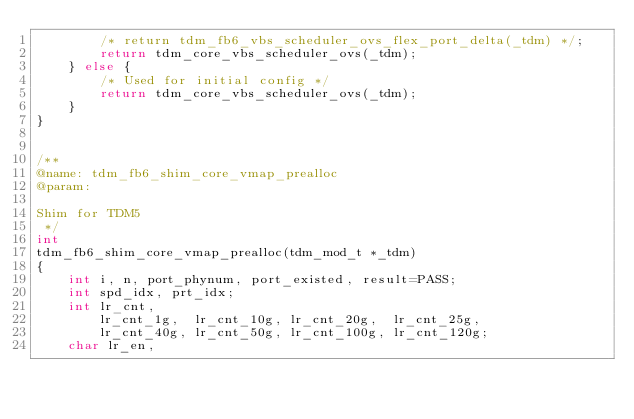<code> <loc_0><loc_0><loc_500><loc_500><_C_>        /* return tdm_fb6_vbs_scheduler_ovs_flex_port_delta(_tdm) */;
        return tdm_core_vbs_scheduler_ovs(_tdm);
    } else {
        /* Used for initial config */
        return tdm_core_vbs_scheduler_ovs(_tdm);
    }
}


/**
@name: tdm_fb6_shim_core_vmap_prealloc
@param:

Shim for TDM5
 */
int
tdm_fb6_shim_core_vmap_prealloc(tdm_mod_t *_tdm)
{
    int i, n, port_phynum, port_existed, result=PASS;
    int spd_idx, prt_idx;
    int lr_cnt,
        lr_cnt_1g,  lr_cnt_10g, lr_cnt_20g,  lr_cnt_25g,
        lr_cnt_40g, lr_cnt_50g, lr_cnt_100g, lr_cnt_120g;
    char lr_en,</code> 